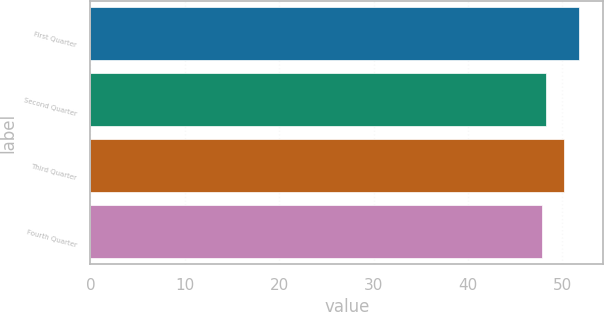<chart> <loc_0><loc_0><loc_500><loc_500><bar_chart><fcel>First Quarter<fcel>Second Quarter<fcel>Third Quarter<fcel>Fourth Quarter<nl><fcel>51.78<fcel>48.27<fcel>50.18<fcel>47.88<nl></chart> 